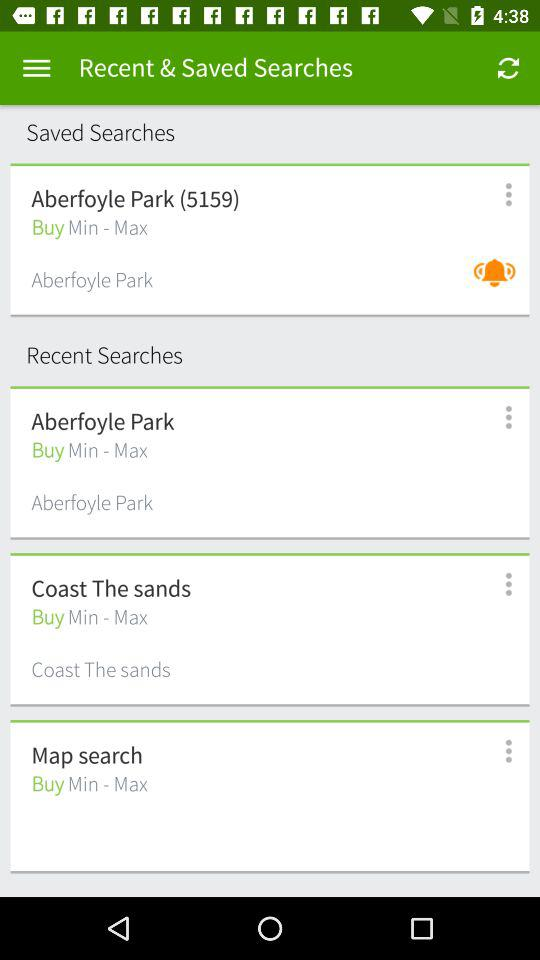How many saved searches have the text 'Aberfoyle Park'?
Answer the question using a single word or phrase. 2 